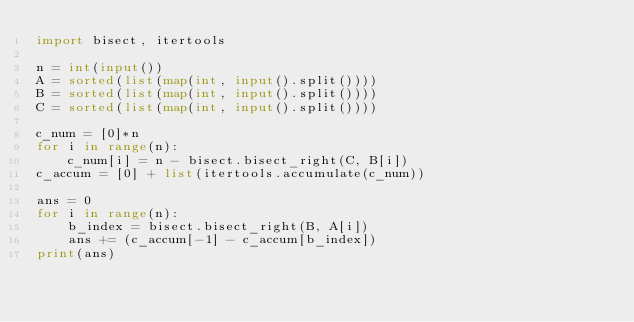Convert code to text. <code><loc_0><loc_0><loc_500><loc_500><_Python_>import bisect, itertools

n = int(input())
A = sorted(list(map(int, input().split())))
B = sorted(list(map(int, input().split())))
C = sorted(list(map(int, input().split())))

c_num = [0]*n
for i in range(n):
    c_num[i] = n - bisect.bisect_right(C, B[i])
c_accum = [0] + list(itertools.accumulate(c_num))

ans = 0
for i in range(n):
    b_index = bisect.bisect_right(B, A[i])
    ans += (c_accum[-1] - c_accum[b_index])
print(ans)</code> 